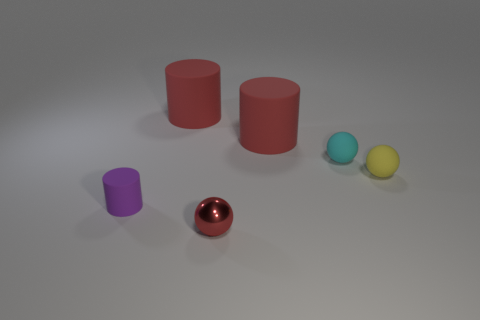Add 4 red things. How many objects exist? 10 Subtract all red matte cylinders. How many cylinders are left? 1 Subtract 1 cylinders. How many cylinders are left? 2 Subtract 1 yellow spheres. How many objects are left? 5 Subtract all red cylinders. Subtract all green balls. How many cylinders are left? 1 Subtract all yellow balls. How many gray cylinders are left? 0 Subtract all tiny shiny things. Subtract all red things. How many objects are left? 2 Add 2 tiny metal things. How many tiny metal things are left? 3 Add 4 tiny blue metal balls. How many tiny blue metal balls exist? 4 Subtract all purple cylinders. How many cylinders are left? 2 